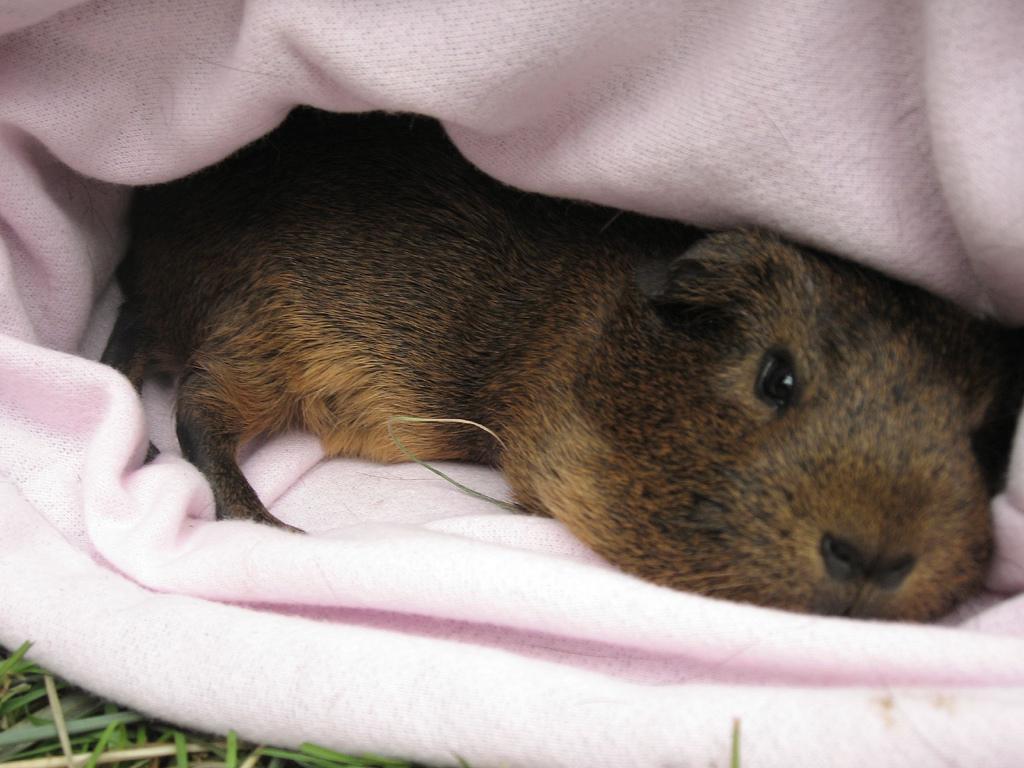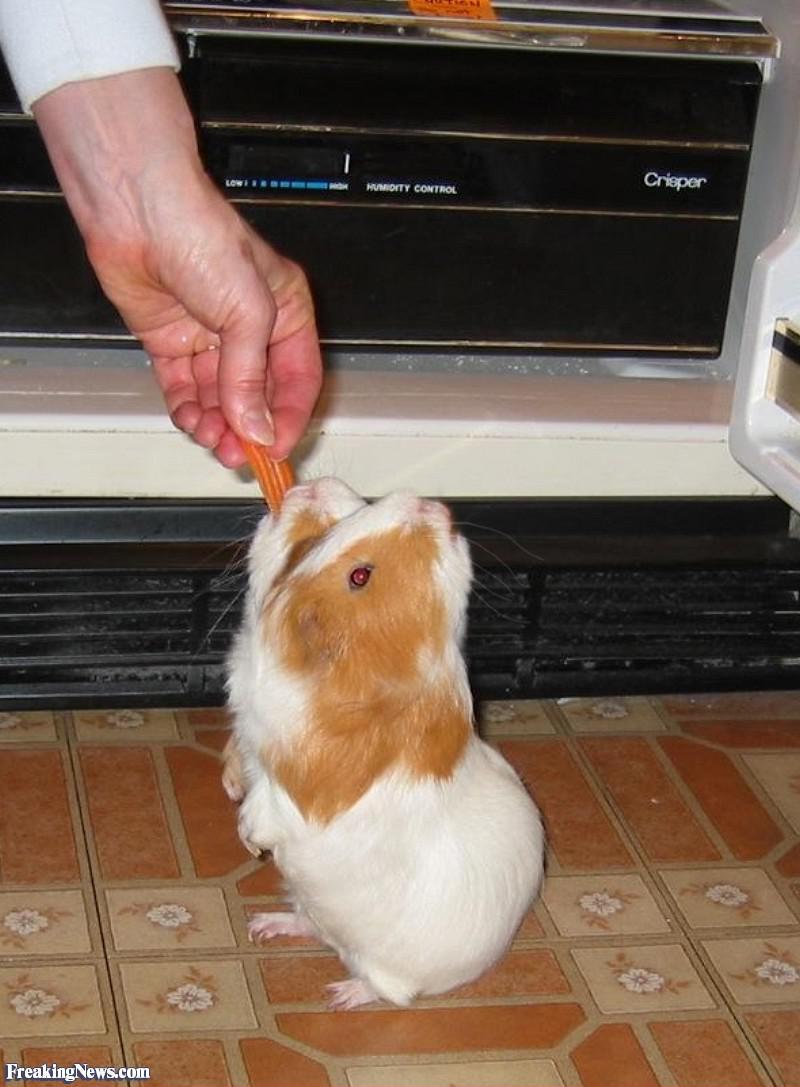The first image is the image on the left, the second image is the image on the right. For the images displayed, is the sentence "The right image has two guinea pigs." factually correct? Answer yes or no. No. The first image is the image on the left, the second image is the image on the right. Considering the images on both sides, is "there is at least one guinea pig in a cardboard box" valid? Answer yes or no. No. 